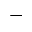<formula> <loc_0><loc_0><loc_500><loc_500>-</formula> 